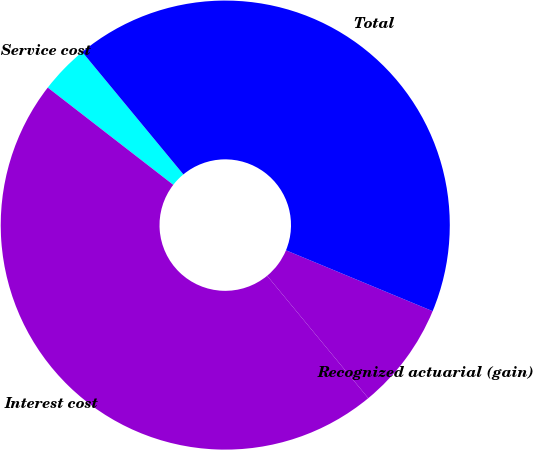Convert chart to OTSL. <chart><loc_0><loc_0><loc_500><loc_500><pie_chart><fcel>Service cost<fcel>Interest cost<fcel>Recognized actuarial (gain)<fcel>Total<nl><fcel>3.52%<fcel>46.48%<fcel>7.75%<fcel>42.25%<nl></chart> 